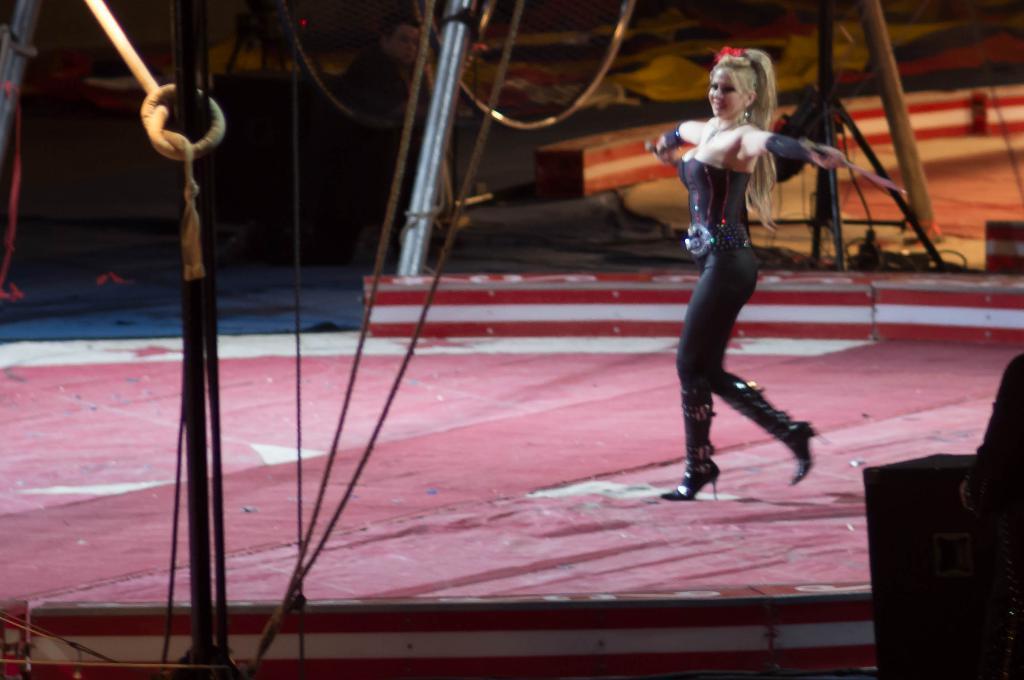Please provide a concise description of this image. In this image we can see a woman wearing black dress. Image also consists of wires, poles and stands. At the bottom we can see a red color carpet on the floor. In the background we can see a blue color carpet. 